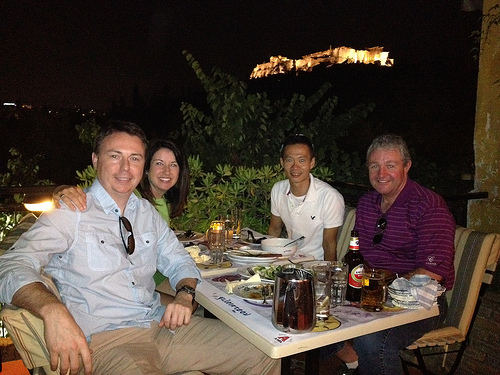Can you describe the mood of the gathering? The individuals seem to be in high spirits, sharing a meal outdoors, indicative of a casual and friendly atmosphere. 